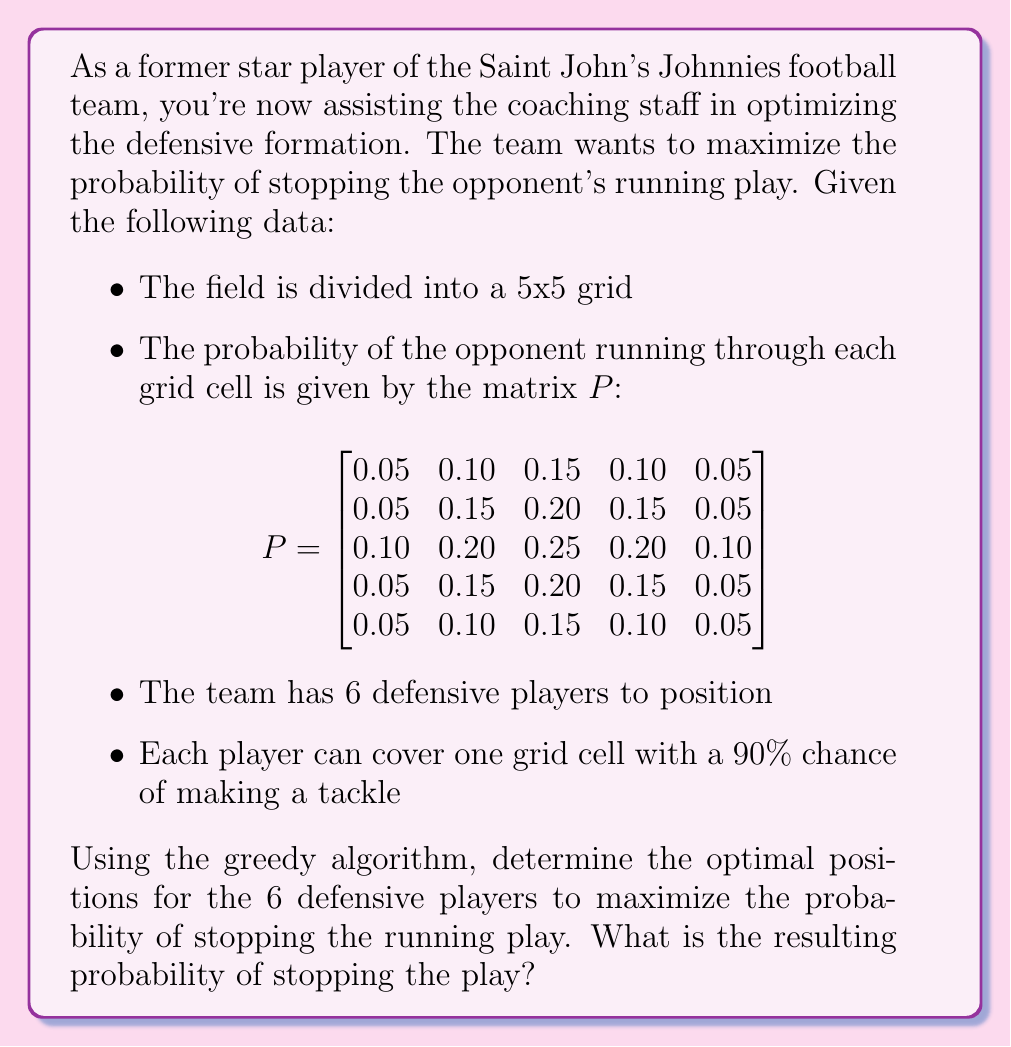Can you answer this question? To solve this problem using the greedy algorithm, we'll follow these steps:

1) The greedy algorithm for this scenario involves placing each defensive player in the cell with the highest remaining probability until all players are positioned.

2) We'll start by identifying the cell with the highest probability in the matrix $P$. This is the center cell with a probability of 0.25.

3) We place the first player in this cell. The probability of stopping the play in this cell is:
   $0.25 \times 0.90 = 0.225$

4) We then update the probability matrix by reducing the probability in this cell to $0.25 \times (1 - 0.90) = 0.025$

5) We repeat this process for the remaining 5 players:

   Player 2: Placed in a cell with 0.20 probability
   Contribution: $0.20 \times 0.90 = 0.180$
   
   Player 3: Placed in another cell with 0.20 probability
   Contribution: $0.20 \times 0.90 = 0.180$
   
   Player 4: Placed in another cell with 0.20 probability
   Contribution: $0.20 \times 0.90 = 0.180$
   
   Player 5: Placed in another cell with 0.20 probability
   Contribution: $0.20 \times 0.90 = 0.180$
   
   Player 6: Placed in a cell with 0.15 probability
   Contribution: $0.15 \times 0.90 = 0.135$

6) To calculate the total probability of stopping the play, we sum up the individual probabilities:

   $P(\text{stop}) = 0.225 + 0.180 + 0.180 + 0.180 + 0.180 + 0.135 = 1.080$

7) However, this sum exceeds 1, which is impossible for a probability. This is because we've counted some overlapping probabilities. To correct this, we need to calculate the probability of not stopping the play and then subtract from 1:

   $P(\text{not stop}) = (1 - 0.225)(1 - 0.180)(1 - 0.180)(1 - 0.180)(1 - 0.180)(1 - 0.135)$
   
   $P(\text{not stop}) = 0.775 \times 0.820 \times 0.820 \times 0.820 \times 0.820 \times 0.865 = 0.3178$

   $P(\text{stop}) = 1 - P(\text{not stop}) = 1 - 0.3178 = 0.6822$

Therefore, the probability of stopping the play with this optimal formation is approximately 0.6822 or 68.22%.
Answer: The optimal positions for the 6 defensive players are: the center cell, the four cells adjacent to the center, and one corner cell of the central 3x3 grid. The resulting probability of stopping the play is approximately 0.6822 or 68.22%. 